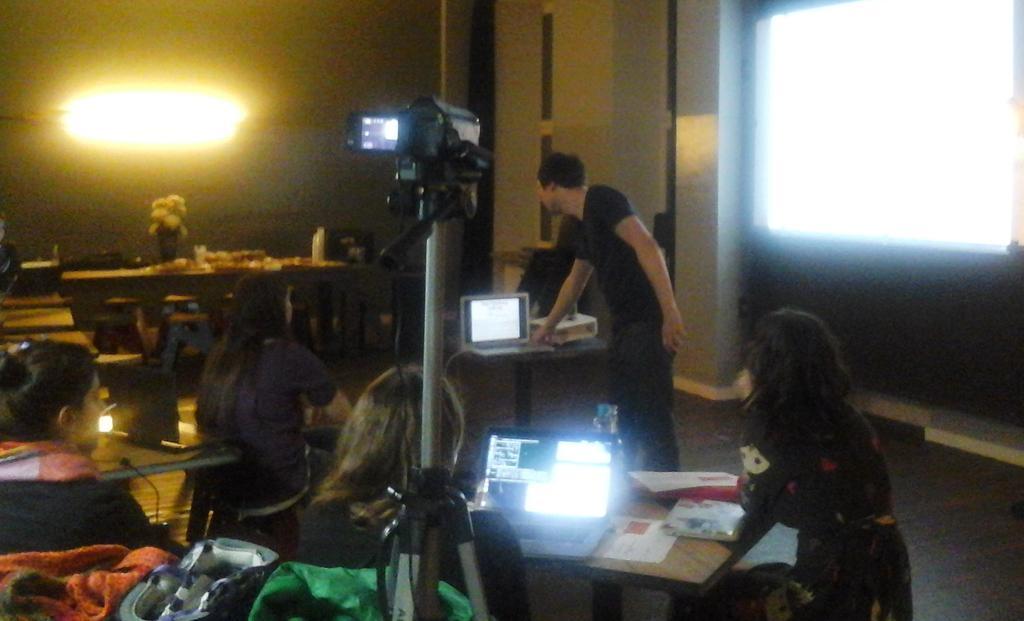Can you describe this image briefly? In the center of the image we can see people sitting and there is a man standing. There are tables and we can see laptops, books and some things placed on the tables. There are bags. There is a camera placed on the stand. In the background there are walls and lights. 